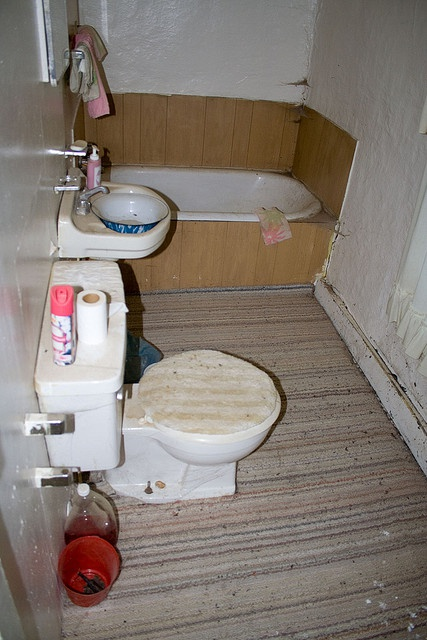Describe the objects in this image and their specific colors. I can see toilet in gray, darkgray, and lightgray tones, sink in gray, darkgray, and lightgray tones, and bottle in gray and darkgray tones in this image. 